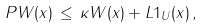<formula> <loc_0><loc_0><loc_500><loc_500>P W ( x ) \, \leq \, \kappa W ( x ) + L { 1 } _ { U } ( x ) \, ,</formula> 